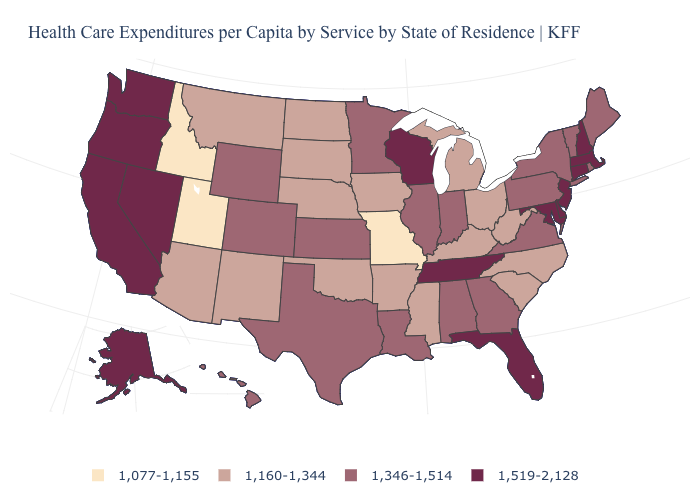How many symbols are there in the legend?
Concise answer only. 4. Is the legend a continuous bar?
Give a very brief answer. No. Which states hav the highest value in the West?
Concise answer only. Alaska, California, Nevada, Oregon, Washington. Does Minnesota have the highest value in the MidWest?
Be succinct. No. What is the value of Massachusetts?
Give a very brief answer. 1,519-2,128. What is the value of Nevada?
Be succinct. 1,519-2,128. Does Virginia have the same value as New York?
Write a very short answer. Yes. What is the highest value in states that border Kansas?
Quick response, please. 1,346-1,514. Name the states that have a value in the range 1,160-1,344?
Write a very short answer. Arizona, Arkansas, Iowa, Kentucky, Michigan, Mississippi, Montana, Nebraska, New Mexico, North Carolina, North Dakota, Ohio, Oklahoma, South Carolina, South Dakota, West Virginia. Which states have the highest value in the USA?
Concise answer only. Alaska, California, Connecticut, Delaware, Florida, Maryland, Massachusetts, Nevada, New Hampshire, New Jersey, Oregon, Tennessee, Washington, Wisconsin. Does Montana have a lower value than Ohio?
Give a very brief answer. No. What is the value of South Carolina?
Keep it brief. 1,160-1,344. Name the states that have a value in the range 1,077-1,155?
Give a very brief answer. Idaho, Missouri, Utah. What is the lowest value in the USA?
Write a very short answer. 1,077-1,155. Name the states that have a value in the range 1,160-1,344?
Keep it brief. Arizona, Arkansas, Iowa, Kentucky, Michigan, Mississippi, Montana, Nebraska, New Mexico, North Carolina, North Dakota, Ohio, Oklahoma, South Carolina, South Dakota, West Virginia. 